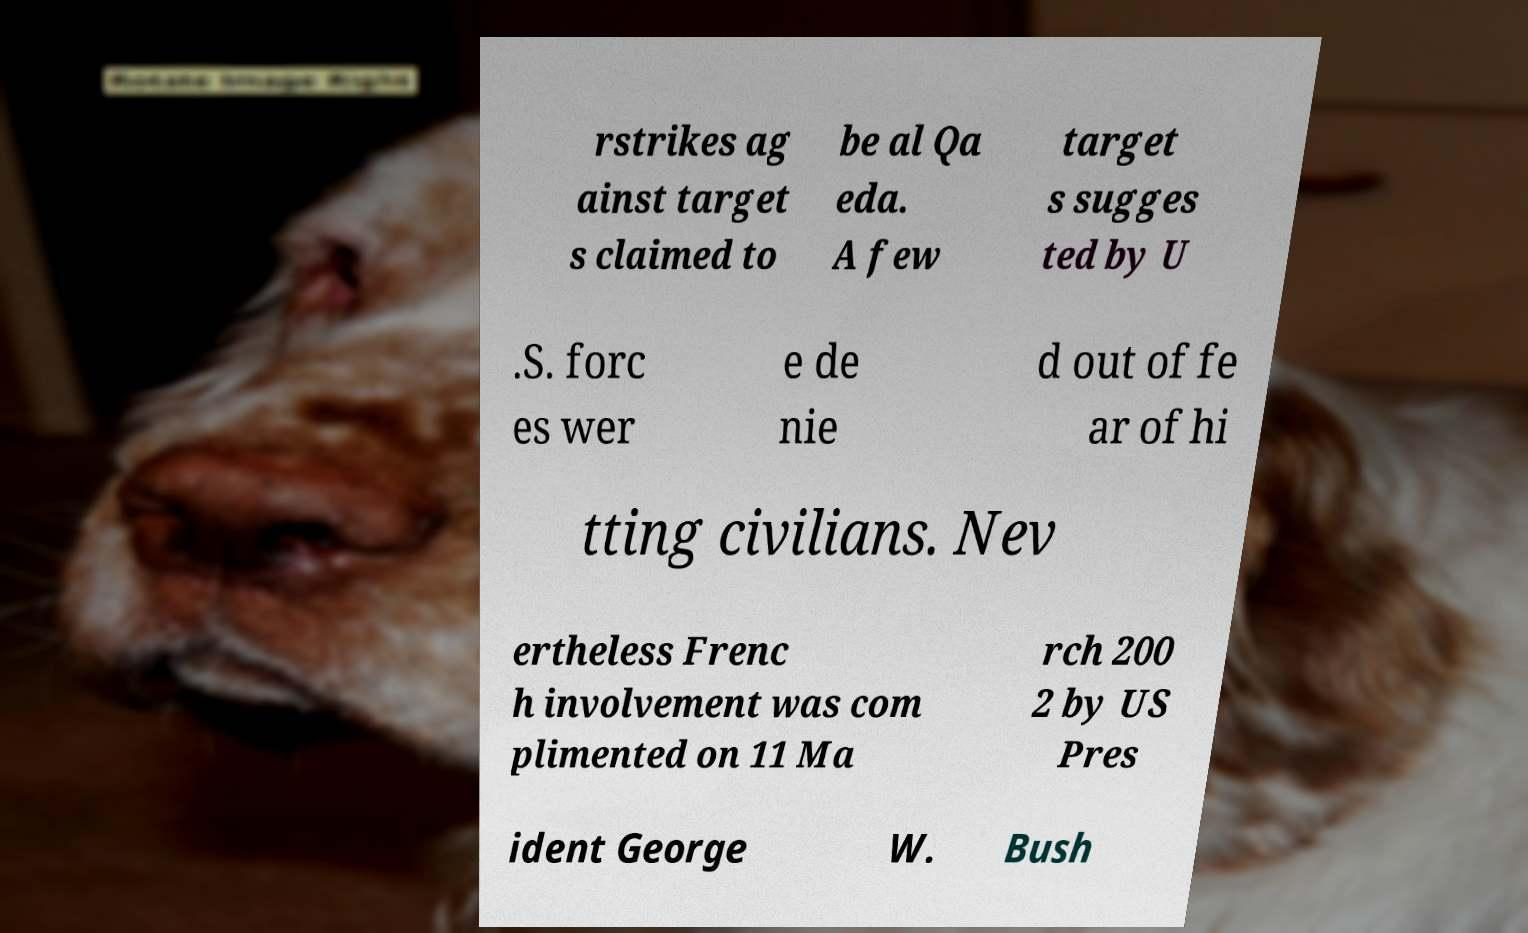What messages or text are displayed in this image? I need them in a readable, typed format. rstrikes ag ainst target s claimed to be al Qa eda. A few target s sugges ted by U .S. forc es wer e de nie d out of fe ar of hi tting civilians. Nev ertheless Frenc h involvement was com plimented on 11 Ma rch 200 2 by US Pres ident George W. Bush 